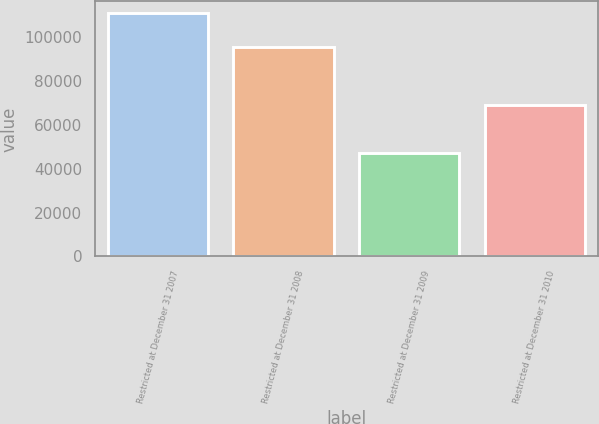Convert chart. <chart><loc_0><loc_0><loc_500><loc_500><bar_chart><fcel>Restricted at December 31 2007<fcel>Restricted at December 31 2008<fcel>Restricted at December 31 2009<fcel>Restricted at December 31 2010<nl><fcel>110593<fcel>95338<fcel>47160<fcel>68791<nl></chart> 